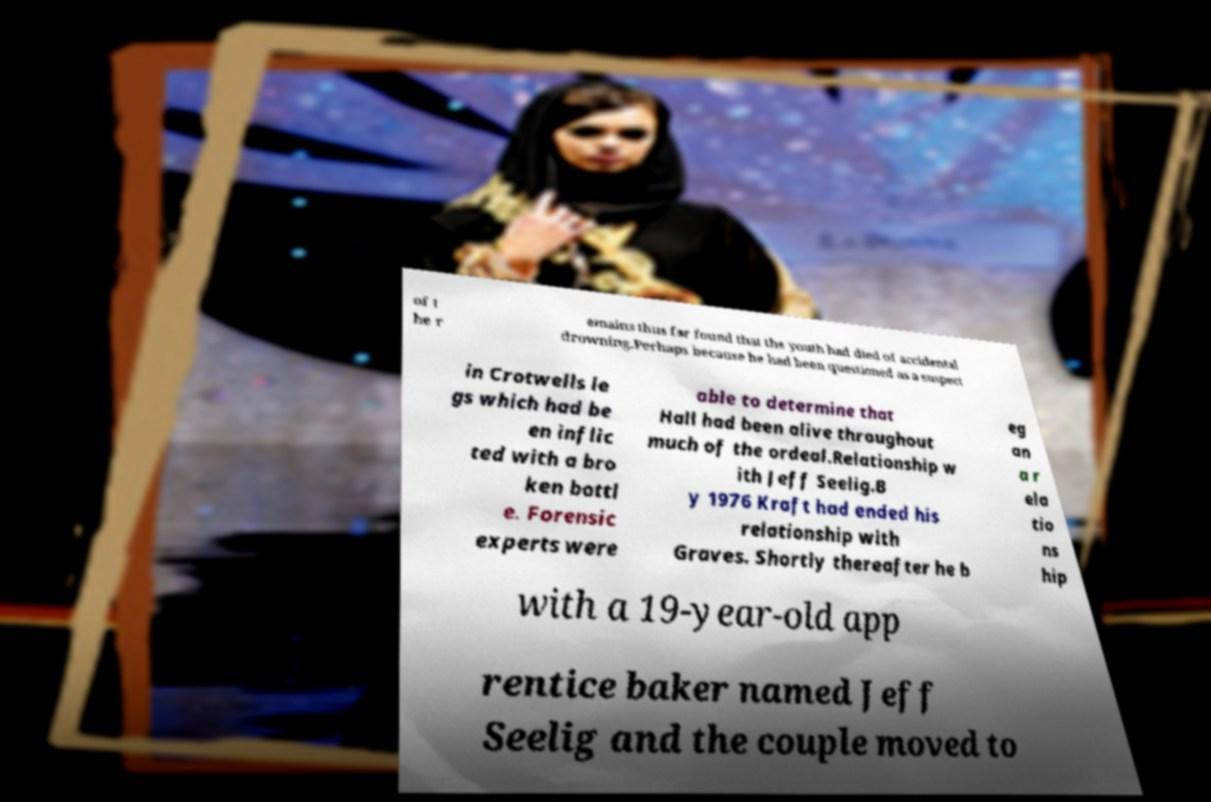Could you extract and type out the text from this image? of t he r emains thus far found that the youth had died of accidental drowning.Perhaps because he had been questioned as a suspect in Crotwells le gs which had be en inflic ted with a bro ken bottl e. Forensic experts were able to determine that Hall had been alive throughout much of the ordeal.Relationship w ith Jeff Seelig.B y 1976 Kraft had ended his relationship with Graves. Shortly thereafter he b eg an a r ela tio ns hip with a 19-year-old app rentice baker named Jeff Seelig and the couple moved to 